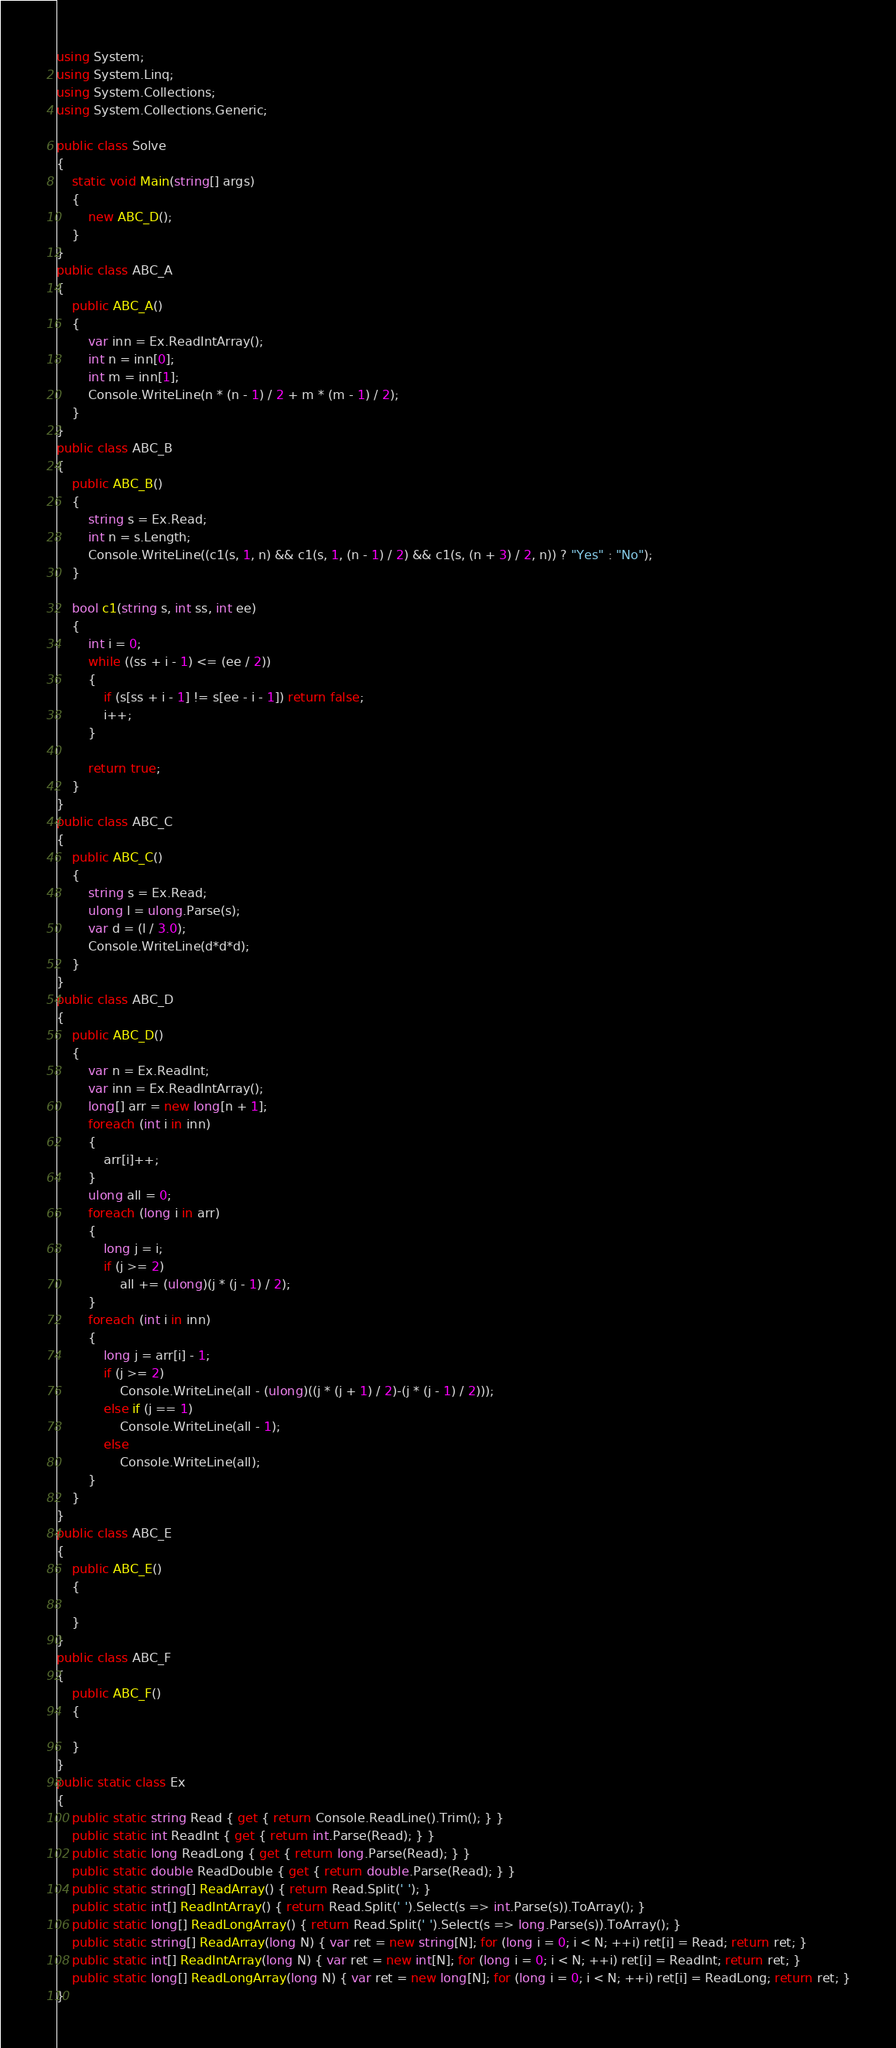Convert code to text. <code><loc_0><loc_0><loc_500><loc_500><_C#_>using System;
using System.Linq;
using System.Collections;
using System.Collections.Generic;

public class Solve
{
    static void Main(string[] args)
    {
        new ABC_D();
    }
}
public class ABC_A
{
    public ABC_A()
    {
        var inn = Ex.ReadIntArray();
        int n = inn[0];
        int m = inn[1];
        Console.WriteLine(n * (n - 1) / 2 + m * (m - 1) / 2);
    }
}
public class ABC_B
{
    public ABC_B()
    {
        string s = Ex.Read;
        int n = s.Length;
        Console.WriteLine((c1(s, 1, n) && c1(s, 1, (n - 1) / 2) && c1(s, (n + 3) / 2, n)) ? "Yes" : "No");
    }

    bool c1(string s, int ss, int ee)
    {
        int i = 0;
        while ((ss + i - 1) <= (ee / 2))
        {
            if (s[ss + i - 1] != s[ee - i - 1]) return false;
            i++;
        }

        return true;
    }
}
public class ABC_C
{
    public ABC_C()
    {
        string s = Ex.Read;
        ulong l = ulong.Parse(s);
        var d = (l / 3.0);
        Console.WriteLine(d*d*d);
    }
}
public class ABC_D
{
    public ABC_D()
    {
        var n = Ex.ReadInt;
        var inn = Ex.ReadIntArray();
        long[] arr = new long[n + 1];
        foreach (int i in inn)
        {
            arr[i]++;
        }
        ulong all = 0;
        foreach (long i in arr)
        {
            long j = i;
            if (j >= 2)
                all += (ulong)(j * (j - 1) / 2);
        }
        foreach (int i in inn)
        {
            long j = arr[i] - 1;
            if (j >= 2)
                Console.WriteLine(all - (ulong)((j * (j + 1) / 2)-(j * (j - 1) / 2)));
            else if (j == 1)
                Console.WriteLine(all - 1);
            else
                Console.WriteLine(all);
        }
    }
}
public class ABC_E
{
    public ABC_E()
    {

    }
}
public class ABC_F
{
    public ABC_F()
    {

    }
}
public static class Ex
{
    public static string Read { get { return Console.ReadLine().Trim(); } }
    public static int ReadInt { get { return int.Parse(Read); } }
    public static long ReadLong { get { return long.Parse(Read); } }
    public static double ReadDouble { get { return double.Parse(Read); } }
    public static string[] ReadArray() { return Read.Split(' '); }
    public static int[] ReadIntArray() { return Read.Split(' ').Select(s => int.Parse(s)).ToArray(); }
    public static long[] ReadLongArray() { return Read.Split(' ').Select(s => long.Parse(s)).ToArray(); }
    public static string[] ReadArray(long N) { var ret = new string[N]; for (long i = 0; i < N; ++i) ret[i] = Read; return ret; }
    public static int[] ReadIntArray(long N) { var ret = new int[N]; for (long i = 0; i < N; ++i) ret[i] = ReadInt; return ret; }
    public static long[] ReadLongArray(long N) { var ret = new long[N]; for (long i = 0; i < N; ++i) ret[i] = ReadLong; return ret; }
}</code> 